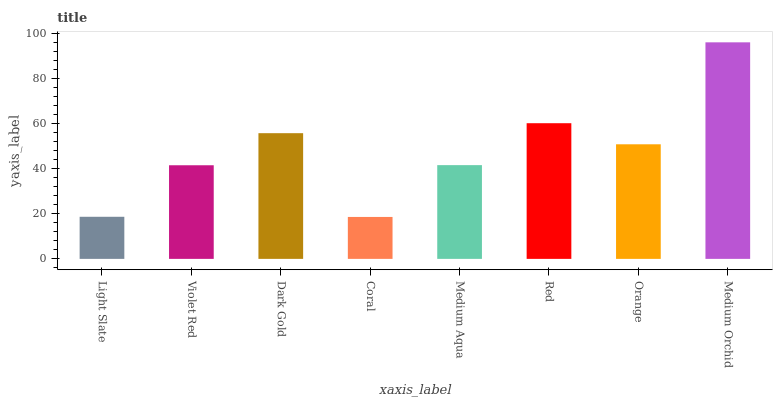Is Coral the minimum?
Answer yes or no. Yes. Is Medium Orchid the maximum?
Answer yes or no. Yes. Is Violet Red the minimum?
Answer yes or no. No. Is Violet Red the maximum?
Answer yes or no. No. Is Violet Red greater than Light Slate?
Answer yes or no. Yes. Is Light Slate less than Violet Red?
Answer yes or no. Yes. Is Light Slate greater than Violet Red?
Answer yes or no. No. Is Violet Red less than Light Slate?
Answer yes or no. No. Is Orange the high median?
Answer yes or no. Yes. Is Medium Aqua the low median?
Answer yes or no. Yes. Is Red the high median?
Answer yes or no. No. Is Light Slate the low median?
Answer yes or no. No. 